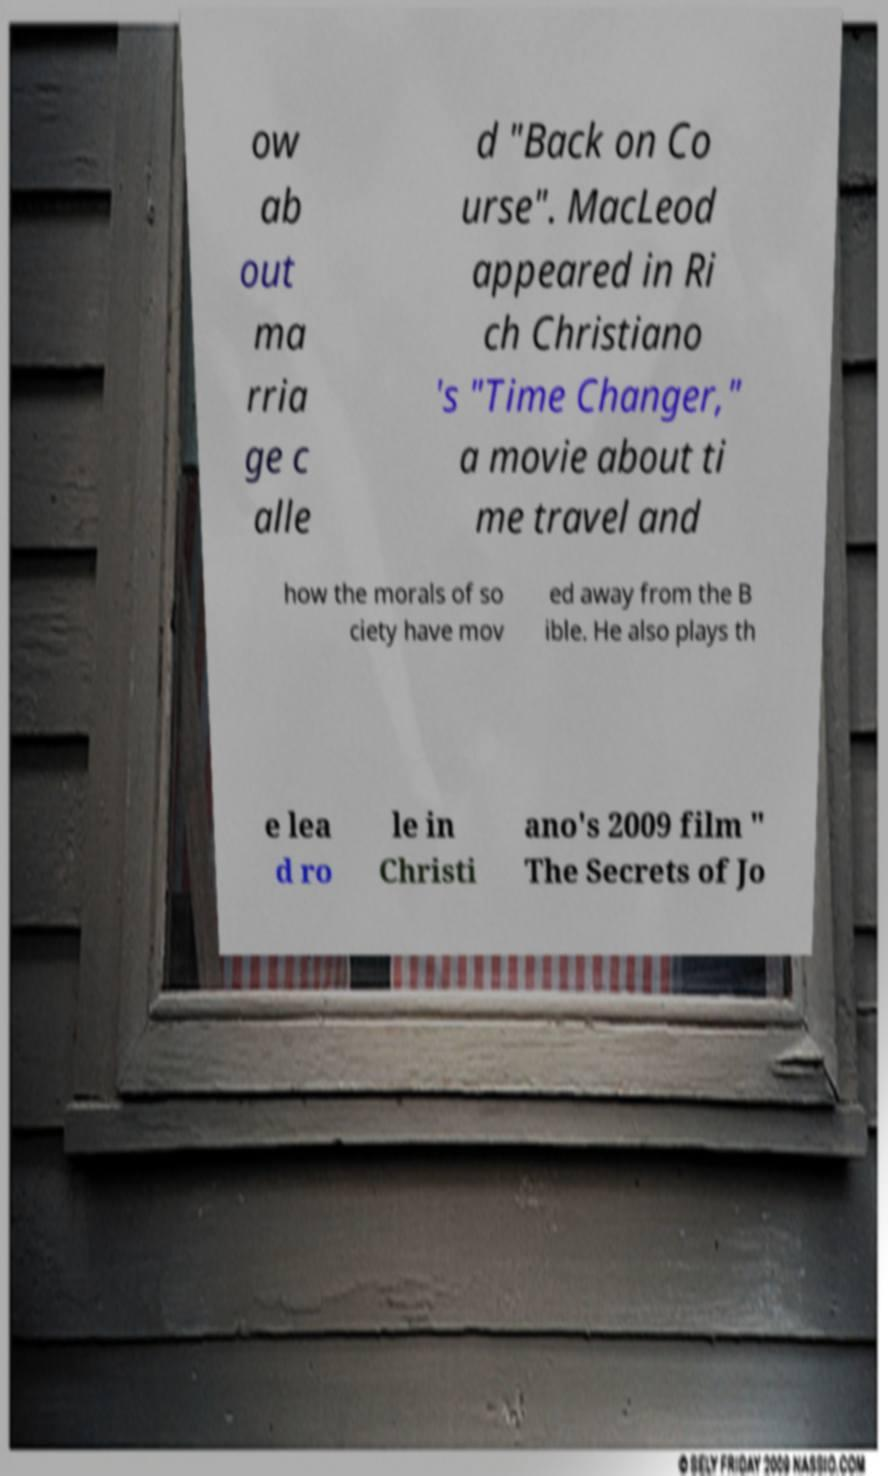For documentation purposes, I need the text within this image transcribed. Could you provide that? ow ab out ma rria ge c alle d "Back on Co urse". MacLeod appeared in Ri ch Christiano 's "Time Changer," a movie about ti me travel and how the morals of so ciety have mov ed away from the B ible. He also plays th e lea d ro le in Christi ano's 2009 film " The Secrets of Jo 